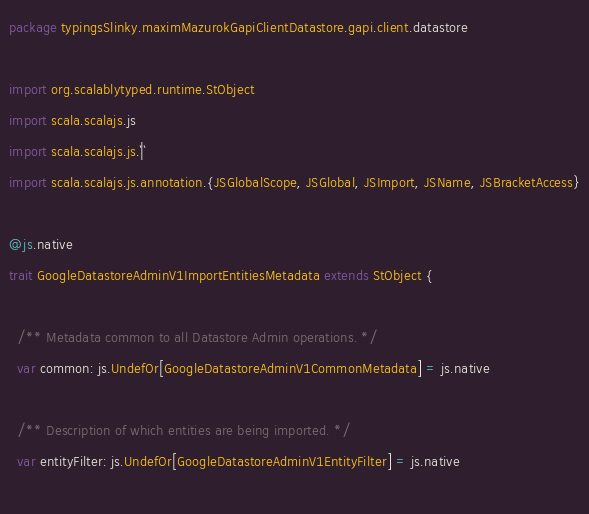Convert code to text. <code><loc_0><loc_0><loc_500><loc_500><_Scala_>package typingsSlinky.maximMazurokGapiClientDatastore.gapi.client.datastore

import org.scalablytyped.runtime.StObject
import scala.scalajs.js
import scala.scalajs.js.`|`
import scala.scalajs.js.annotation.{JSGlobalScope, JSGlobal, JSImport, JSName, JSBracketAccess}

@js.native
trait GoogleDatastoreAdminV1ImportEntitiesMetadata extends StObject {
  
  /** Metadata common to all Datastore Admin operations. */
  var common: js.UndefOr[GoogleDatastoreAdminV1CommonMetadata] = js.native
  
  /** Description of which entities are being imported. */
  var entityFilter: js.UndefOr[GoogleDatastoreAdminV1EntityFilter] = js.native
  </code> 